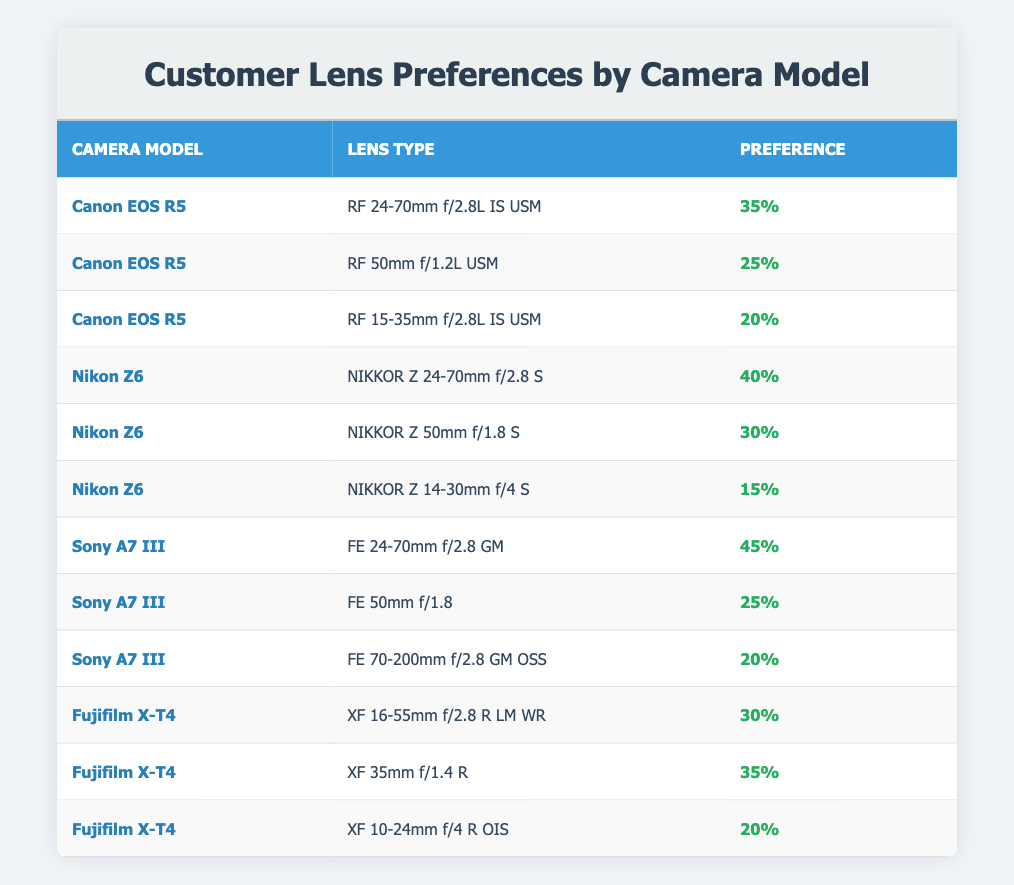What lens type has the highest preference for the Canon EOS R5? According to the table, the lens type with the highest preference for the Canon EOS R5 is the RF 24-70mm f/2.8L IS USM, which has a preference percentage of 35.
Answer: RF 24-70mm f/2.8L IS USM Is it true that the NIKKOR Z 50mm f/1.8 S has a higher preference than the NIKKOR Z 14-30mm f/4 S? Yes, the preference percentage for the NIKKOR Z 50mm f/1.8 S is 30%, while the preference for the NIKKOR Z 14-30mm f/4 S is 15%. Thus, the NIKKOR Z 50mm f/1.8 S has a higher preference.
Answer: Yes What is the total preference percentage for all lens types associated with the Sony A7 III? The lens types for Sony A7 III and their preference percentages are: FE 24-70mm f/2.8 GM (45), FE 50mm f/1.8 (25), and FE 70-200mm f/2.8 GM OSS (20). Summing these, we have 45 + 25 + 20 = 90.
Answer: 90 Which camera model has the lowest preferred lens type percentage, and what is that percentage? The camera model with the lowest preferred lens type is the Nikon Z6 with the NIKKOR Z 14-30mm f/4 S, which has a preference percentage of 15.
Answer: Nikon Z6, 15 What is the average preference percentage of lens types for the Fujifilm X-T4? The lens types for Fujifilm X-T4 are XF 16-55mm f/2.8 R LM WR (30), XF 35mm f/1.4 R (35), and XF 10-24mm f/4 R OIS (20). Adding these gives 30 + 35 + 20 = 85. Dividing by the number of lens types, we have 85/3 = 28.33. Thus, the average preference is approximately 28.33.
Answer: 28.33 Does the RF 15-35mm f/2.8L IS USM have a higher preference than both the XF 10-24mm f/4 R OIS and the FE 70-200mm f/2.8 GM OSS? Yes, the RF 15-35mm f/2.8L IS USM has a preference of 20, while both the XF 10-24mm f/4 R OIS and the FE 70-200mm f/2.8 GM OSS have lower preferences of 20 and 20, respectively, so it is equal to one and higher than the other.
Answer: Yes Which lens type has a preference percentage equal to 25 and what camera model does it belong to? The lens type with a preference percentage of 25 is the RF 50mm f/1.2L USM, which belongs to the Canon EOS R5.
Answer: RF 50mm f/1.2L USM, Canon EOS R5 